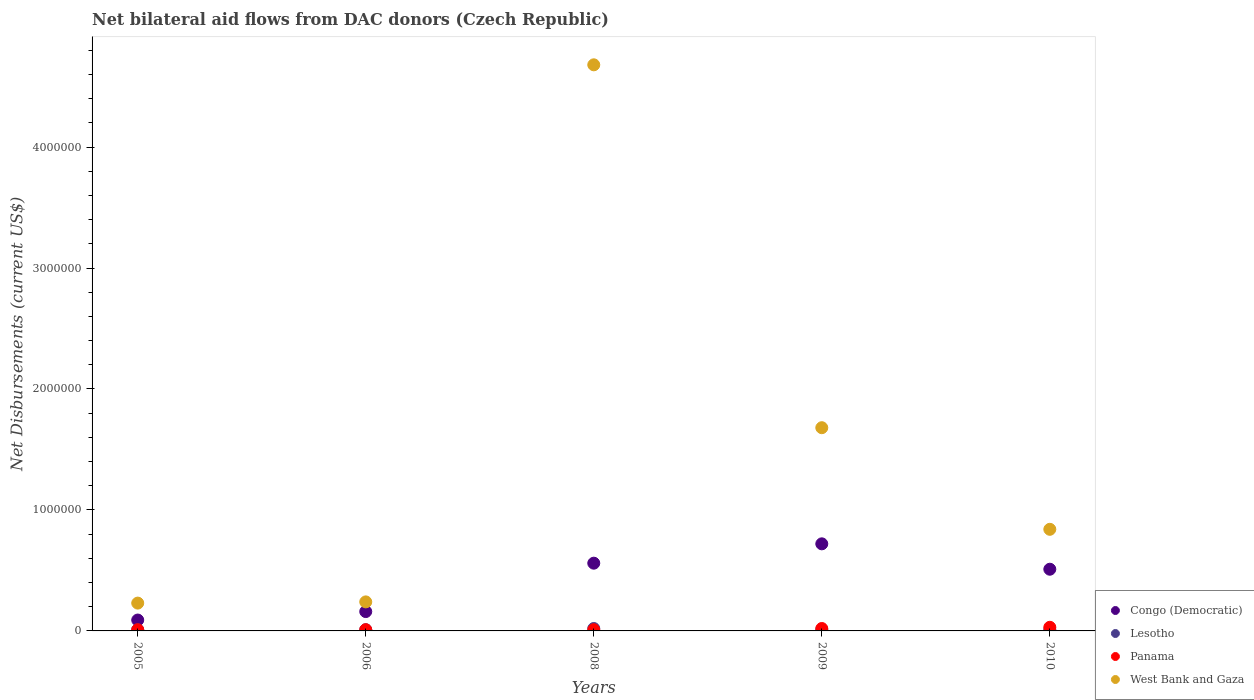How many different coloured dotlines are there?
Provide a succinct answer. 4. What is the net bilateral aid flows in Panama in 2005?
Ensure brevity in your answer.  10000. Across all years, what is the maximum net bilateral aid flows in Congo (Democratic)?
Your answer should be very brief. 7.20e+05. Across all years, what is the minimum net bilateral aid flows in West Bank and Gaza?
Give a very brief answer. 2.30e+05. In which year was the net bilateral aid flows in Congo (Democratic) maximum?
Ensure brevity in your answer.  2009. In which year was the net bilateral aid flows in Lesotho minimum?
Your answer should be very brief. 2005. What is the total net bilateral aid flows in Congo (Democratic) in the graph?
Make the answer very short. 2.04e+06. What is the difference between the net bilateral aid flows in Congo (Democratic) in 2008 and that in 2009?
Make the answer very short. -1.60e+05. What is the difference between the net bilateral aid flows in Lesotho in 2006 and the net bilateral aid flows in Congo (Democratic) in 2010?
Keep it short and to the point. -5.00e+05. What is the average net bilateral aid flows in Panama per year?
Make the answer very short. 1.60e+04. In the year 2006, what is the difference between the net bilateral aid flows in Lesotho and net bilateral aid flows in Panama?
Your answer should be very brief. 0. In how many years, is the net bilateral aid flows in Panama greater than 4200000 US$?
Ensure brevity in your answer.  0. What is the ratio of the net bilateral aid flows in Congo (Democratic) in 2005 to that in 2008?
Your answer should be compact. 0.16. Is the difference between the net bilateral aid flows in Lesotho in 2005 and 2008 greater than the difference between the net bilateral aid flows in Panama in 2005 and 2008?
Give a very brief answer. No. What is the difference between the highest and the second highest net bilateral aid flows in Panama?
Provide a short and direct response. 10000. What is the difference between the highest and the lowest net bilateral aid flows in West Bank and Gaza?
Ensure brevity in your answer.  4.45e+06. Is it the case that in every year, the sum of the net bilateral aid flows in West Bank and Gaza and net bilateral aid flows in Congo (Democratic)  is greater than the sum of net bilateral aid flows in Panama and net bilateral aid flows in Lesotho?
Make the answer very short. Yes. Is it the case that in every year, the sum of the net bilateral aid flows in Congo (Democratic) and net bilateral aid flows in Panama  is greater than the net bilateral aid flows in West Bank and Gaza?
Provide a succinct answer. No. Is the net bilateral aid flows in Panama strictly less than the net bilateral aid flows in Congo (Democratic) over the years?
Your answer should be very brief. Yes. How many dotlines are there?
Your answer should be very brief. 4. How many years are there in the graph?
Your answer should be very brief. 5. Does the graph contain any zero values?
Ensure brevity in your answer.  No. Does the graph contain grids?
Your response must be concise. No. How many legend labels are there?
Give a very brief answer. 4. How are the legend labels stacked?
Your response must be concise. Vertical. What is the title of the graph?
Ensure brevity in your answer.  Net bilateral aid flows from DAC donors (Czech Republic). Does "Montenegro" appear as one of the legend labels in the graph?
Your response must be concise. No. What is the label or title of the Y-axis?
Your answer should be compact. Net Disbursements (current US$). What is the Net Disbursements (current US$) of Lesotho in 2005?
Give a very brief answer. 10000. What is the Net Disbursements (current US$) of Panama in 2005?
Give a very brief answer. 10000. What is the Net Disbursements (current US$) in Lesotho in 2006?
Keep it short and to the point. 10000. What is the Net Disbursements (current US$) in Congo (Democratic) in 2008?
Keep it short and to the point. 5.60e+05. What is the Net Disbursements (current US$) of Lesotho in 2008?
Provide a succinct answer. 2.00e+04. What is the Net Disbursements (current US$) in West Bank and Gaza in 2008?
Offer a very short reply. 4.68e+06. What is the Net Disbursements (current US$) in Congo (Democratic) in 2009?
Offer a very short reply. 7.20e+05. What is the Net Disbursements (current US$) in Lesotho in 2009?
Give a very brief answer. 10000. What is the Net Disbursements (current US$) in Panama in 2009?
Offer a terse response. 2.00e+04. What is the Net Disbursements (current US$) of West Bank and Gaza in 2009?
Keep it short and to the point. 1.68e+06. What is the Net Disbursements (current US$) of Congo (Democratic) in 2010?
Offer a very short reply. 5.10e+05. What is the Net Disbursements (current US$) in Panama in 2010?
Offer a very short reply. 3.00e+04. What is the Net Disbursements (current US$) in West Bank and Gaza in 2010?
Keep it short and to the point. 8.40e+05. Across all years, what is the maximum Net Disbursements (current US$) of Congo (Democratic)?
Make the answer very short. 7.20e+05. Across all years, what is the maximum Net Disbursements (current US$) of Lesotho?
Keep it short and to the point. 2.00e+04. Across all years, what is the maximum Net Disbursements (current US$) of West Bank and Gaza?
Make the answer very short. 4.68e+06. Across all years, what is the minimum Net Disbursements (current US$) in Panama?
Offer a terse response. 10000. Across all years, what is the minimum Net Disbursements (current US$) of West Bank and Gaza?
Make the answer very short. 2.30e+05. What is the total Net Disbursements (current US$) of Congo (Democratic) in the graph?
Your answer should be compact. 2.04e+06. What is the total Net Disbursements (current US$) of West Bank and Gaza in the graph?
Make the answer very short. 7.67e+06. What is the difference between the Net Disbursements (current US$) in West Bank and Gaza in 2005 and that in 2006?
Keep it short and to the point. -10000. What is the difference between the Net Disbursements (current US$) of Congo (Democratic) in 2005 and that in 2008?
Your answer should be compact. -4.70e+05. What is the difference between the Net Disbursements (current US$) of Lesotho in 2005 and that in 2008?
Provide a short and direct response. -10000. What is the difference between the Net Disbursements (current US$) of West Bank and Gaza in 2005 and that in 2008?
Ensure brevity in your answer.  -4.45e+06. What is the difference between the Net Disbursements (current US$) in Congo (Democratic) in 2005 and that in 2009?
Offer a very short reply. -6.30e+05. What is the difference between the Net Disbursements (current US$) in Lesotho in 2005 and that in 2009?
Your answer should be very brief. 0. What is the difference between the Net Disbursements (current US$) of West Bank and Gaza in 2005 and that in 2009?
Provide a short and direct response. -1.45e+06. What is the difference between the Net Disbursements (current US$) of Congo (Democratic) in 2005 and that in 2010?
Ensure brevity in your answer.  -4.20e+05. What is the difference between the Net Disbursements (current US$) of Lesotho in 2005 and that in 2010?
Your answer should be very brief. 0. What is the difference between the Net Disbursements (current US$) in West Bank and Gaza in 2005 and that in 2010?
Make the answer very short. -6.10e+05. What is the difference between the Net Disbursements (current US$) in Congo (Democratic) in 2006 and that in 2008?
Offer a very short reply. -4.00e+05. What is the difference between the Net Disbursements (current US$) of Panama in 2006 and that in 2008?
Your response must be concise. 0. What is the difference between the Net Disbursements (current US$) of West Bank and Gaza in 2006 and that in 2008?
Make the answer very short. -4.44e+06. What is the difference between the Net Disbursements (current US$) in Congo (Democratic) in 2006 and that in 2009?
Make the answer very short. -5.60e+05. What is the difference between the Net Disbursements (current US$) of West Bank and Gaza in 2006 and that in 2009?
Provide a short and direct response. -1.44e+06. What is the difference between the Net Disbursements (current US$) in Congo (Democratic) in 2006 and that in 2010?
Provide a short and direct response. -3.50e+05. What is the difference between the Net Disbursements (current US$) of Lesotho in 2006 and that in 2010?
Provide a short and direct response. 0. What is the difference between the Net Disbursements (current US$) of West Bank and Gaza in 2006 and that in 2010?
Ensure brevity in your answer.  -6.00e+05. What is the difference between the Net Disbursements (current US$) in Panama in 2008 and that in 2009?
Your answer should be very brief. -10000. What is the difference between the Net Disbursements (current US$) in West Bank and Gaza in 2008 and that in 2009?
Ensure brevity in your answer.  3.00e+06. What is the difference between the Net Disbursements (current US$) of West Bank and Gaza in 2008 and that in 2010?
Offer a very short reply. 3.84e+06. What is the difference between the Net Disbursements (current US$) in Congo (Democratic) in 2009 and that in 2010?
Provide a short and direct response. 2.10e+05. What is the difference between the Net Disbursements (current US$) in Lesotho in 2009 and that in 2010?
Your answer should be compact. 0. What is the difference between the Net Disbursements (current US$) in West Bank and Gaza in 2009 and that in 2010?
Your response must be concise. 8.40e+05. What is the difference between the Net Disbursements (current US$) in Congo (Democratic) in 2005 and the Net Disbursements (current US$) in Lesotho in 2006?
Provide a short and direct response. 8.00e+04. What is the difference between the Net Disbursements (current US$) in Congo (Democratic) in 2005 and the Net Disbursements (current US$) in Panama in 2006?
Your answer should be very brief. 8.00e+04. What is the difference between the Net Disbursements (current US$) of Congo (Democratic) in 2005 and the Net Disbursements (current US$) of Panama in 2008?
Provide a succinct answer. 8.00e+04. What is the difference between the Net Disbursements (current US$) in Congo (Democratic) in 2005 and the Net Disbursements (current US$) in West Bank and Gaza in 2008?
Provide a succinct answer. -4.59e+06. What is the difference between the Net Disbursements (current US$) of Lesotho in 2005 and the Net Disbursements (current US$) of West Bank and Gaza in 2008?
Your answer should be compact. -4.67e+06. What is the difference between the Net Disbursements (current US$) of Panama in 2005 and the Net Disbursements (current US$) of West Bank and Gaza in 2008?
Give a very brief answer. -4.67e+06. What is the difference between the Net Disbursements (current US$) in Congo (Democratic) in 2005 and the Net Disbursements (current US$) in West Bank and Gaza in 2009?
Your answer should be very brief. -1.59e+06. What is the difference between the Net Disbursements (current US$) in Lesotho in 2005 and the Net Disbursements (current US$) in West Bank and Gaza in 2009?
Provide a short and direct response. -1.67e+06. What is the difference between the Net Disbursements (current US$) of Panama in 2005 and the Net Disbursements (current US$) of West Bank and Gaza in 2009?
Make the answer very short. -1.67e+06. What is the difference between the Net Disbursements (current US$) of Congo (Democratic) in 2005 and the Net Disbursements (current US$) of Lesotho in 2010?
Provide a short and direct response. 8.00e+04. What is the difference between the Net Disbursements (current US$) of Congo (Democratic) in 2005 and the Net Disbursements (current US$) of West Bank and Gaza in 2010?
Your answer should be very brief. -7.50e+05. What is the difference between the Net Disbursements (current US$) in Lesotho in 2005 and the Net Disbursements (current US$) in Panama in 2010?
Keep it short and to the point. -2.00e+04. What is the difference between the Net Disbursements (current US$) in Lesotho in 2005 and the Net Disbursements (current US$) in West Bank and Gaza in 2010?
Make the answer very short. -8.30e+05. What is the difference between the Net Disbursements (current US$) in Panama in 2005 and the Net Disbursements (current US$) in West Bank and Gaza in 2010?
Provide a succinct answer. -8.30e+05. What is the difference between the Net Disbursements (current US$) of Congo (Democratic) in 2006 and the Net Disbursements (current US$) of Lesotho in 2008?
Offer a terse response. 1.40e+05. What is the difference between the Net Disbursements (current US$) in Congo (Democratic) in 2006 and the Net Disbursements (current US$) in West Bank and Gaza in 2008?
Provide a succinct answer. -4.52e+06. What is the difference between the Net Disbursements (current US$) of Lesotho in 2006 and the Net Disbursements (current US$) of Panama in 2008?
Make the answer very short. 0. What is the difference between the Net Disbursements (current US$) in Lesotho in 2006 and the Net Disbursements (current US$) in West Bank and Gaza in 2008?
Keep it short and to the point. -4.67e+06. What is the difference between the Net Disbursements (current US$) in Panama in 2006 and the Net Disbursements (current US$) in West Bank and Gaza in 2008?
Provide a succinct answer. -4.67e+06. What is the difference between the Net Disbursements (current US$) in Congo (Democratic) in 2006 and the Net Disbursements (current US$) in Lesotho in 2009?
Offer a terse response. 1.50e+05. What is the difference between the Net Disbursements (current US$) of Congo (Democratic) in 2006 and the Net Disbursements (current US$) of Panama in 2009?
Your answer should be compact. 1.40e+05. What is the difference between the Net Disbursements (current US$) of Congo (Democratic) in 2006 and the Net Disbursements (current US$) of West Bank and Gaza in 2009?
Keep it short and to the point. -1.52e+06. What is the difference between the Net Disbursements (current US$) of Lesotho in 2006 and the Net Disbursements (current US$) of West Bank and Gaza in 2009?
Keep it short and to the point. -1.67e+06. What is the difference between the Net Disbursements (current US$) in Panama in 2006 and the Net Disbursements (current US$) in West Bank and Gaza in 2009?
Your response must be concise. -1.67e+06. What is the difference between the Net Disbursements (current US$) of Congo (Democratic) in 2006 and the Net Disbursements (current US$) of Lesotho in 2010?
Ensure brevity in your answer.  1.50e+05. What is the difference between the Net Disbursements (current US$) in Congo (Democratic) in 2006 and the Net Disbursements (current US$) in Panama in 2010?
Offer a terse response. 1.30e+05. What is the difference between the Net Disbursements (current US$) of Congo (Democratic) in 2006 and the Net Disbursements (current US$) of West Bank and Gaza in 2010?
Provide a succinct answer. -6.80e+05. What is the difference between the Net Disbursements (current US$) in Lesotho in 2006 and the Net Disbursements (current US$) in West Bank and Gaza in 2010?
Offer a terse response. -8.30e+05. What is the difference between the Net Disbursements (current US$) of Panama in 2006 and the Net Disbursements (current US$) of West Bank and Gaza in 2010?
Ensure brevity in your answer.  -8.30e+05. What is the difference between the Net Disbursements (current US$) of Congo (Democratic) in 2008 and the Net Disbursements (current US$) of Panama in 2009?
Offer a terse response. 5.40e+05. What is the difference between the Net Disbursements (current US$) of Congo (Democratic) in 2008 and the Net Disbursements (current US$) of West Bank and Gaza in 2009?
Provide a succinct answer. -1.12e+06. What is the difference between the Net Disbursements (current US$) in Lesotho in 2008 and the Net Disbursements (current US$) in West Bank and Gaza in 2009?
Your response must be concise. -1.66e+06. What is the difference between the Net Disbursements (current US$) of Panama in 2008 and the Net Disbursements (current US$) of West Bank and Gaza in 2009?
Provide a succinct answer. -1.67e+06. What is the difference between the Net Disbursements (current US$) of Congo (Democratic) in 2008 and the Net Disbursements (current US$) of Lesotho in 2010?
Your answer should be very brief. 5.50e+05. What is the difference between the Net Disbursements (current US$) of Congo (Democratic) in 2008 and the Net Disbursements (current US$) of Panama in 2010?
Your response must be concise. 5.30e+05. What is the difference between the Net Disbursements (current US$) of Congo (Democratic) in 2008 and the Net Disbursements (current US$) of West Bank and Gaza in 2010?
Make the answer very short. -2.80e+05. What is the difference between the Net Disbursements (current US$) of Lesotho in 2008 and the Net Disbursements (current US$) of West Bank and Gaza in 2010?
Make the answer very short. -8.20e+05. What is the difference between the Net Disbursements (current US$) in Panama in 2008 and the Net Disbursements (current US$) in West Bank and Gaza in 2010?
Give a very brief answer. -8.30e+05. What is the difference between the Net Disbursements (current US$) of Congo (Democratic) in 2009 and the Net Disbursements (current US$) of Lesotho in 2010?
Offer a very short reply. 7.10e+05. What is the difference between the Net Disbursements (current US$) in Congo (Democratic) in 2009 and the Net Disbursements (current US$) in Panama in 2010?
Give a very brief answer. 6.90e+05. What is the difference between the Net Disbursements (current US$) of Lesotho in 2009 and the Net Disbursements (current US$) of West Bank and Gaza in 2010?
Offer a very short reply. -8.30e+05. What is the difference between the Net Disbursements (current US$) of Panama in 2009 and the Net Disbursements (current US$) of West Bank and Gaza in 2010?
Offer a terse response. -8.20e+05. What is the average Net Disbursements (current US$) of Congo (Democratic) per year?
Offer a terse response. 4.08e+05. What is the average Net Disbursements (current US$) of Lesotho per year?
Your answer should be compact. 1.20e+04. What is the average Net Disbursements (current US$) in Panama per year?
Offer a terse response. 1.60e+04. What is the average Net Disbursements (current US$) in West Bank and Gaza per year?
Provide a short and direct response. 1.53e+06. In the year 2005, what is the difference between the Net Disbursements (current US$) of Congo (Democratic) and Net Disbursements (current US$) of Lesotho?
Offer a terse response. 8.00e+04. In the year 2005, what is the difference between the Net Disbursements (current US$) in Congo (Democratic) and Net Disbursements (current US$) in Panama?
Your answer should be very brief. 8.00e+04. In the year 2005, what is the difference between the Net Disbursements (current US$) in Lesotho and Net Disbursements (current US$) in Panama?
Offer a terse response. 0. In the year 2005, what is the difference between the Net Disbursements (current US$) of Panama and Net Disbursements (current US$) of West Bank and Gaza?
Keep it short and to the point. -2.20e+05. In the year 2006, what is the difference between the Net Disbursements (current US$) of Congo (Democratic) and Net Disbursements (current US$) of West Bank and Gaza?
Keep it short and to the point. -8.00e+04. In the year 2008, what is the difference between the Net Disbursements (current US$) of Congo (Democratic) and Net Disbursements (current US$) of Lesotho?
Offer a terse response. 5.40e+05. In the year 2008, what is the difference between the Net Disbursements (current US$) of Congo (Democratic) and Net Disbursements (current US$) of Panama?
Keep it short and to the point. 5.50e+05. In the year 2008, what is the difference between the Net Disbursements (current US$) in Congo (Democratic) and Net Disbursements (current US$) in West Bank and Gaza?
Keep it short and to the point. -4.12e+06. In the year 2008, what is the difference between the Net Disbursements (current US$) of Lesotho and Net Disbursements (current US$) of West Bank and Gaza?
Make the answer very short. -4.66e+06. In the year 2008, what is the difference between the Net Disbursements (current US$) of Panama and Net Disbursements (current US$) of West Bank and Gaza?
Offer a very short reply. -4.67e+06. In the year 2009, what is the difference between the Net Disbursements (current US$) in Congo (Democratic) and Net Disbursements (current US$) in Lesotho?
Ensure brevity in your answer.  7.10e+05. In the year 2009, what is the difference between the Net Disbursements (current US$) of Congo (Democratic) and Net Disbursements (current US$) of West Bank and Gaza?
Your answer should be very brief. -9.60e+05. In the year 2009, what is the difference between the Net Disbursements (current US$) in Lesotho and Net Disbursements (current US$) in Panama?
Provide a short and direct response. -10000. In the year 2009, what is the difference between the Net Disbursements (current US$) in Lesotho and Net Disbursements (current US$) in West Bank and Gaza?
Provide a short and direct response. -1.67e+06. In the year 2009, what is the difference between the Net Disbursements (current US$) in Panama and Net Disbursements (current US$) in West Bank and Gaza?
Keep it short and to the point. -1.66e+06. In the year 2010, what is the difference between the Net Disbursements (current US$) of Congo (Democratic) and Net Disbursements (current US$) of Panama?
Ensure brevity in your answer.  4.80e+05. In the year 2010, what is the difference between the Net Disbursements (current US$) in Congo (Democratic) and Net Disbursements (current US$) in West Bank and Gaza?
Offer a terse response. -3.30e+05. In the year 2010, what is the difference between the Net Disbursements (current US$) in Lesotho and Net Disbursements (current US$) in West Bank and Gaza?
Your answer should be very brief. -8.30e+05. In the year 2010, what is the difference between the Net Disbursements (current US$) of Panama and Net Disbursements (current US$) of West Bank and Gaza?
Provide a succinct answer. -8.10e+05. What is the ratio of the Net Disbursements (current US$) of Congo (Democratic) in 2005 to that in 2006?
Provide a short and direct response. 0.56. What is the ratio of the Net Disbursements (current US$) in Lesotho in 2005 to that in 2006?
Make the answer very short. 1. What is the ratio of the Net Disbursements (current US$) of Congo (Democratic) in 2005 to that in 2008?
Provide a succinct answer. 0.16. What is the ratio of the Net Disbursements (current US$) of Lesotho in 2005 to that in 2008?
Provide a succinct answer. 0.5. What is the ratio of the Net Disbursements (current US$) in Panama in 2005 to that in 2008?
Your answer should be compact. 1. What is the ratio of the Net Disbursements (current US$) in West Bank and Gaza in 2005 to that in 2008?
Make the answer very short. 0.05. What is the ratio of the Net Disbursements (current US$) of West Bank and Gaza in 2005 to that in 2009?
Your answer should be very brief. 0.14. What is the ratio of the Net Disbursements (current US$) of Congo (Democratic) in 2005 to that in 2010?
Offer a very short reply. 0.18. What is the ratio of the Net Disbursements (current US$) of West Bank and Gaza in 2005 to that in 2010?
Provide a succinct answer. 0.27. What is the ratio of the Net Disbursements (current US$) of Congo (Democratic) in 2006 to that in 2008?
Your answer should be very brief. 0.29. What is the ratio of the Net Disbursements (current US$) in Panama in 2006 to that in 2008?
Ensure brevity in your answer.  1. What is the ratio of the Net Disbursements (current US$) in West Bank and Gaza in 2006 to that in 2008?
Offer a very short reply. 0.05. What is the ratio of the Net Disbursements (current US$) in Congo (Democratic) in 2006 to that in 2009?
Offer a terse response. 0.22. What is the ratio of the Net Disbursements (current US$) in Lesotho in 2006 to that in 2009?
Provide a succinct answer. 1. What is the ratio of the Net Disbursements (current US$) of Panama in 2006 to that in 2009?
Offer a very short reply. 0.5. What is the ratio of the Net Disbursements (current US$) in West Bank and Gaza in 2006 to that in 2009?
Provide a succinct answer. 0.14. What is the ratio of the Net Disbursements (current US$) in Congo (Democratic) in 2006 to that in 2010?
Offer a very short reply. 0.31. What is the ratio of the Net Disbursements (current US$) of Lesotho in 2006 to that in 2010?
Your response must be concise. 1. What is the ratio of the Net Disbursements (current US$) of Panama in 2006 to that in 2010?
Provide a short and direct response. 0.33. What is the ratio of the Net Disbursements (current US$) in West Bank and Gaza in 2006 to that in 2010?
Offer a very short reply. 0.29. What is the ratio of the Net Disbursements (current US$) of Lesotho in 2008 to that in 2009?
Offer a terse response. 2. What is the ratio of the Net Disbursements (current US$) of West Bank and Gaza in 2008 to that in 2009?
Provide a short and direct response. 2.79. What is the ratio of the Net Disbursements (current US$) in Congo (Democratic) in 2008 to that in 2010?
Ensure brevity in your answer.  1.1. What is the ratio of the Net Disbursements (current US$) of West Bank and Gaza in 2008 to that in 2010?
Give a very brief answer. 5.57. What is the ratio of the Net Disbursements (current US$) in Congo (Democratic) in 2009 to that in 2010?
Your response must be concise. 1.41. What is the ratio of the Net Disbursements (current US$) in Lesotho in 2009 to that in 2010?
Provide a succinct answer. 1. What is the ratio of the Net Disbursements (current US$) in Panama in 2009 to that in 2010?
Your answer should be compact. 0.67. What is the difference between the highest and the second highest Net Disbursements (current US$) of Lesotho?
Your response must be concise. 10000. What is the difference between the highest and the second highest Net Disbursements (current US$) of West Bank and Gaza?
Ensure brevity in your answer.  3.00e+06. What is the difference between the highest and the lowest Net Disbursements (current US$) in Congo (Democratic)?
Offer a very short reply. 6.30e+05. What is the difference between the highest and the lowest Net Disbursements (current US$) in Lesotho?
Provide a short and direct response. 10000. What is the difference between the highest and the lowest Net Disbursements (current US$) in Panama?
Provide a succinct answer. 2.00e+04. What is the difference between the highest and the lowest Net Disbursements (current US$) in West Bank and Gaza?
Your answer should be compact. 4.45e+06. 